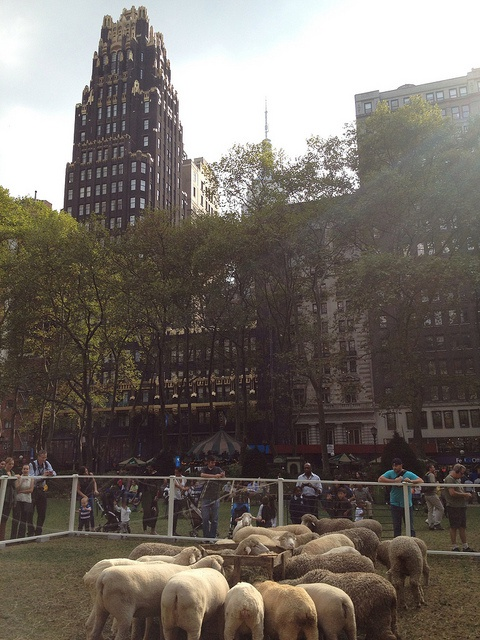Describe the objects in this image and their specific colors. I can see sheep in lightgray, gray, and tan tones, people in lightgray, black, and gray tones, sheep in lightgray, gray, maroon, black, and tan tones, sheep in lightgray, black, gray, and maroon tones, and sheep in lightgray, maroon, gray, tan, and beige tones in this image. 